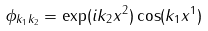Convert formula to latex. <formula><loc_0><loc_0><loc_500><loc_500>\phi _ { k _ { 1 } k _ { 2 } } = \exp ( i k _ { 2 } x ^ { 2 } ) \cos ( k _ { 1 } x ^ { 1 } )</formula> 